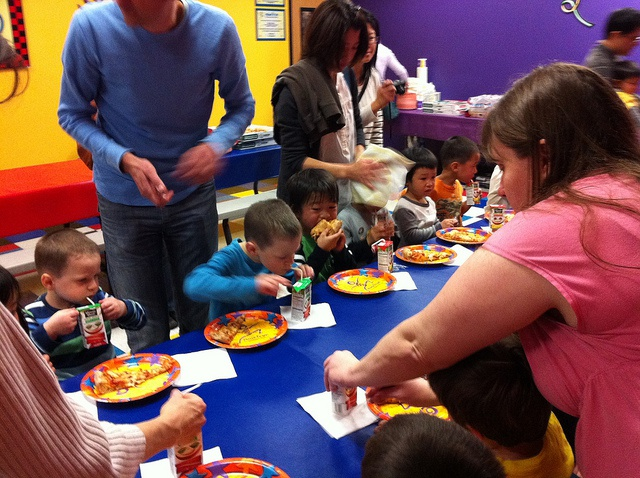Describe the objects in this image and their specific colors. I can see people in gold, brown, black, maroon, and salmon tones, dining table in gold, darkblue, white, blue, and navy tones, people in gold, black, navy, blue, and maroon tones, people in gold, maroon, brown, lightpink, and lightgray tones, and people in gold, black, maroon, brown, and gray tones in this image. 